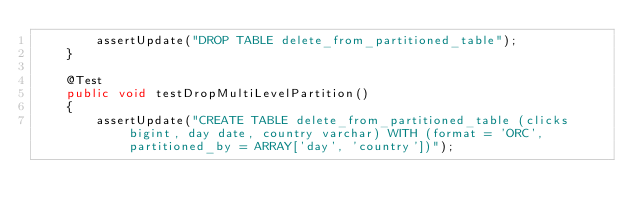Convert code to text. <code><loc_0><loc_0><loc_500><loc_500><_Java_>        assertUpdate("DROP TABLE delete_from_partitioned_table");
    }

    @Test
    public void testDropMultiLevelPartition()
    {
        assertUpdate("CREATE TABLE delete_from_partitioned_table (clicks bigint, day date, country varchar) WITH (format = 'ORC', partitioned_by = ARRAY['day', 'country'])");</code> 